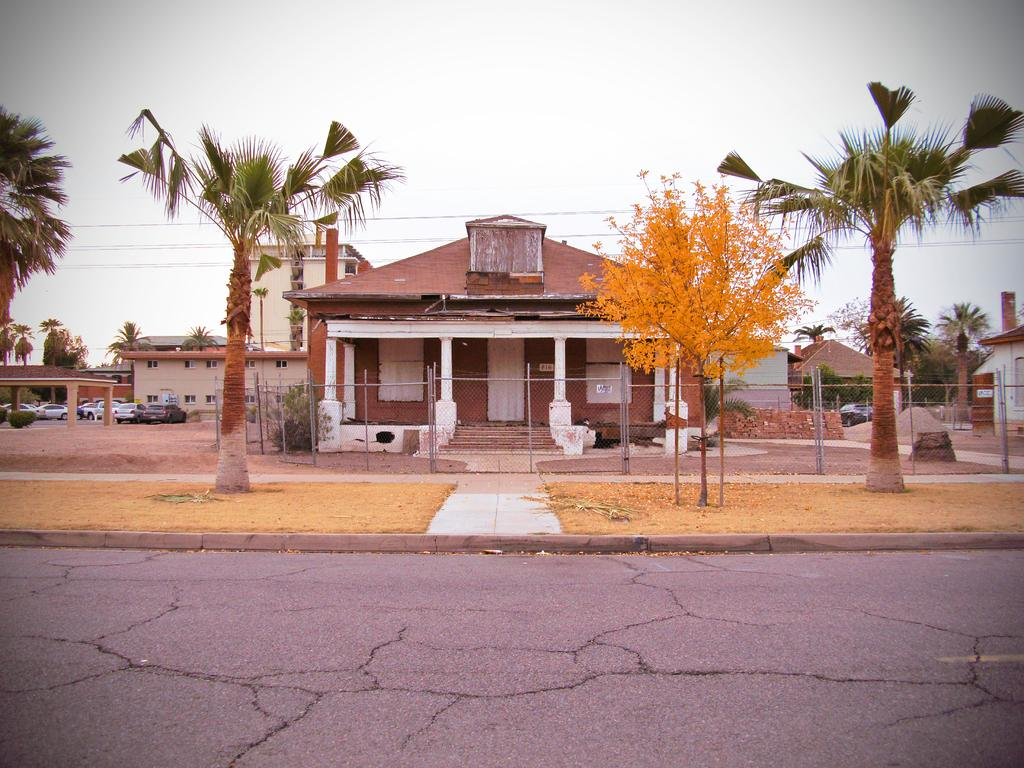What is the main feature of the image? There is a road in the image. What type of natural environment can be seen in the image? There are many trees and grass visible in the image. What type of structures are present in the image? There are houses in the image. What else can be seen on the road in the image? There are many vehicles present in the image. What is the condition of the sky in the image? The sky is clear in the image. What type of fence is present in the image? There is an iron pole fence in the image. What type of rice is being cooked in the image? There is no rice present in the image; it features a road, trees, grass, houses, vehicles, and an iron pole fence. What type of acoustics can be heard in the image? There is no sound or acoustics mentioned in the image, as it is a still image. 